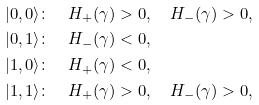Convert formula to latex. <formula><loc_0><loc_0><loc_500><loc_500>& | 0 , 0 \rangle \colon \quad H _ { + } ( \gamma ) > 0 , \quad H _ { - } ( \gamma ) > 0 , \\ & | 0 , 1 \rangle \colon \quad H _ { - } ( \gamma ) < 0 , \\ & | 1 , 0 \rangle \colon \quad H _ { + } ( \gamma ) < 0 , \\ & | 1 , 1 \rangle \colon \quad H _ { + } ( \gamma ) > 0 , \quad H _ { - } ( \gamma ) > 0 ,</formula> 